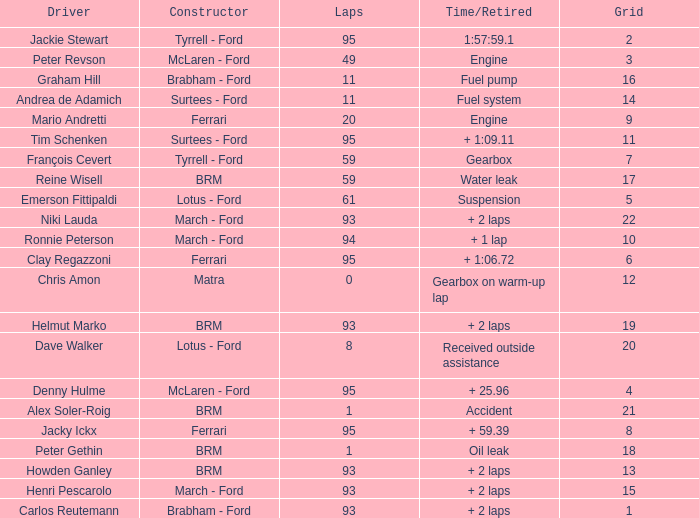What is the lowest grid with matra as constructor? 12.0. 